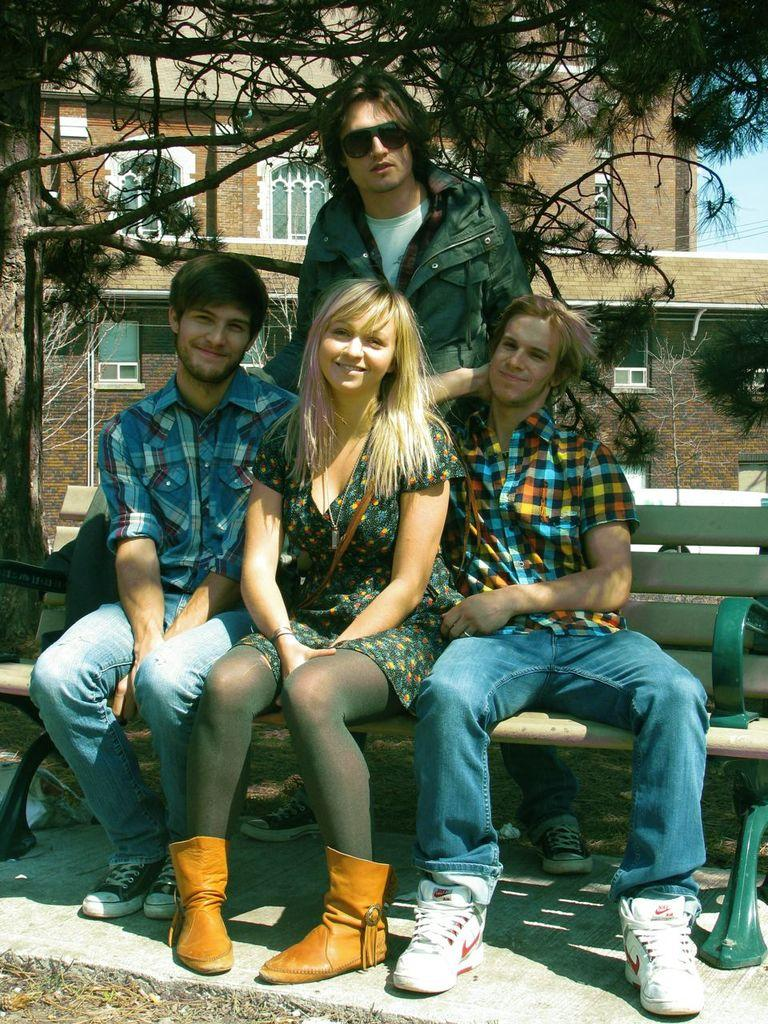How many people are sitting on the bench in the image? There are three people sitting on a bench in the image. What is the position of the person behind them? There is a person standing behind the three people sitting on the bench. What can be seen in the background of the image? There are trees and a building in the background of the image. What type of market is visible in the image? There is no market present in the image; it features people sitting on a bench and a person standing behind them, with trees and a building in the background. 